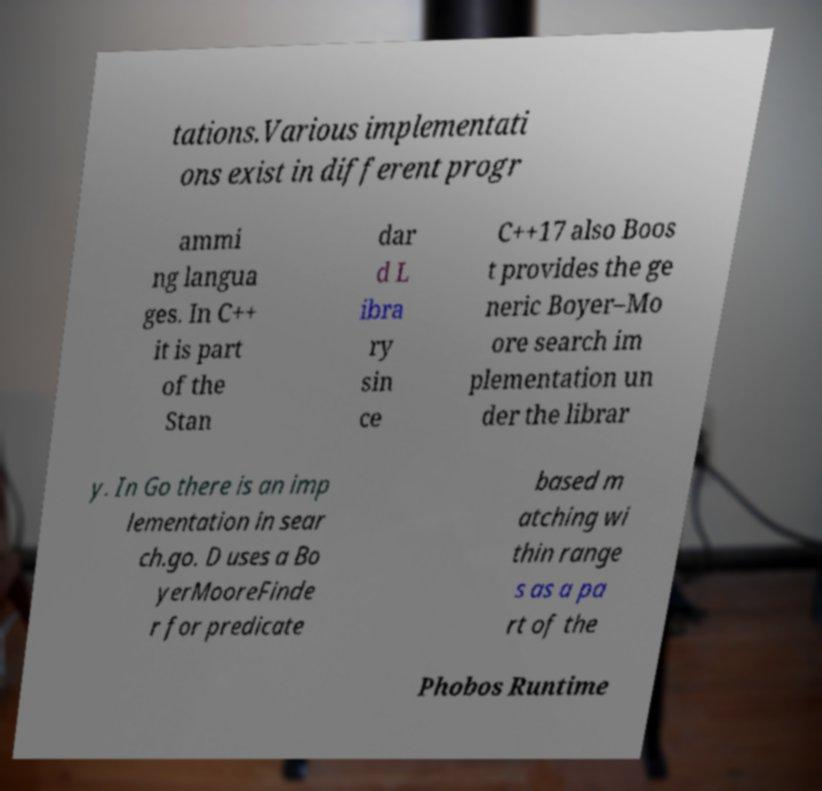Can you accurately transcribe the text from the provided image for me? tations.Various implementati ons exist in different progr ammi ng langua ges. In C++ it is part of the Stan dar d L ibra ry sin ce C++17 also Boos t provides the ge neric Boyer–Mo ore search im plementation un der the librar y. In Go there is an imp lementation in sear ch.go. D uses a Bo yerMooreFinde r for predicate based m atching wi thin range s as a pa rt of the Phobos Runtime 